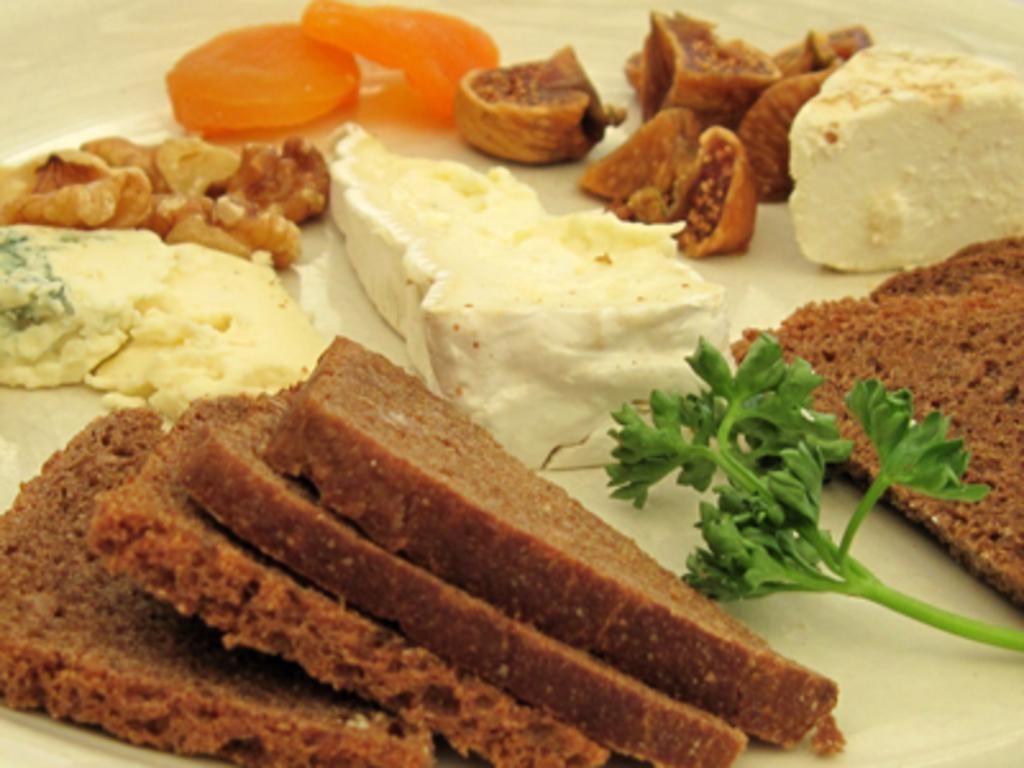What type of objects can be seen in the image? There are eatable things in the image. Where are the eatable things placed? The eatable things are placed on a white surface. What type of wool is used to make the fork in the image? There is no fork present in the image, as the facts only mention eatable things placed on a white surface. 